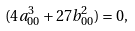<formula> <loc_0><loc_0><loc_500><loc_500>( 4 a _ { 0 0 } ^ { 3 } + 2 7 b _ { 0 0 } ^ { 2 } ) = 0 ,</formula> 